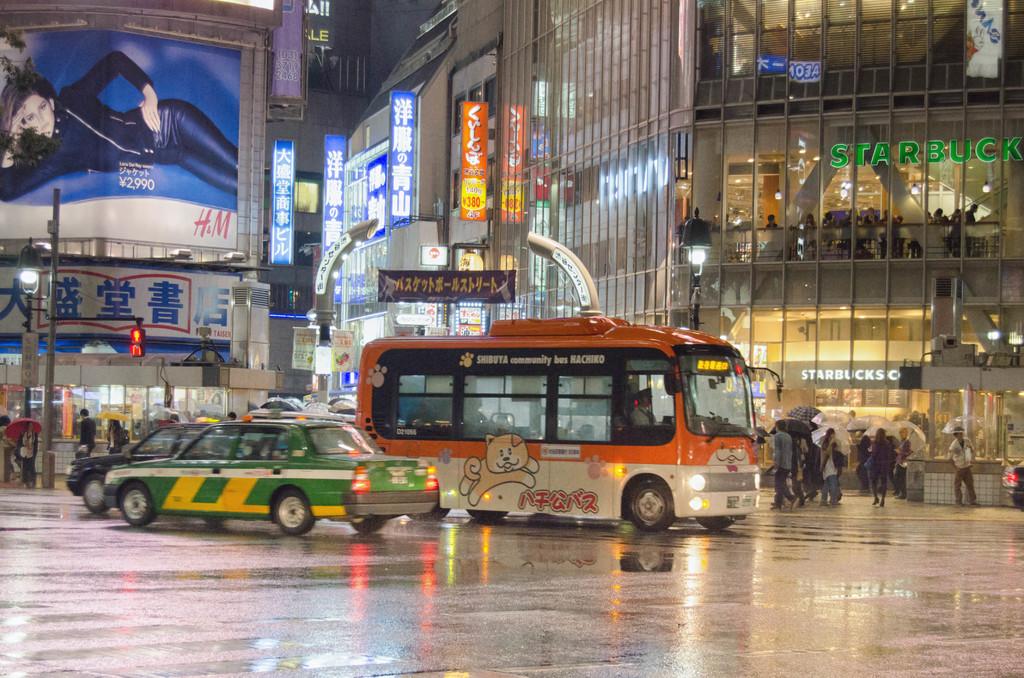What is the orange and white vehicle?
Make the answer very short. Bus. What coffee shop is on the first and second floors?
Your response must be concise. Starbucks. 